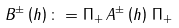Convert formula to latex. <formula><loc_0><loc_0><loc_500><loc_500>B ^ { \pm } \left ( h \right ) \colon = \Pi _ { + } \, A ^ { \pm } \left ( h \right ) \, \Pi _ { + }</formula> 